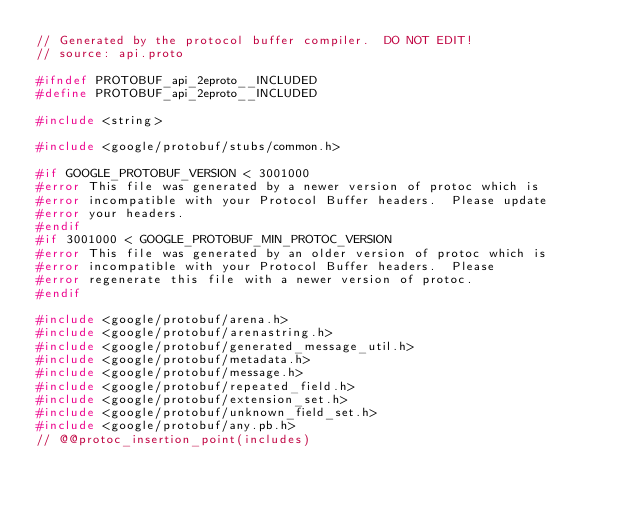Convert code to text. <code><loc_0><loc_0><loc_500><loc_500><_C_>// Generated by the protocol buffer compiler.  DO NOT EDIT!
// source: api.proto

#ifndef PROTOBUF_api_2eproto__INCLUDED
#define PROTOBUF_api_2eproto__INCLUDED

#include <string>

#include <google/protobuf/stubs/common.h>

#if GOOGLE_PROTOBUF_VERSION < 3001000
#error This file was generated by a newer version of protoc which is
#error incompatible with your Protocol Buffer headers.  Please update
#error your headers.
#endif
#if 3001000 < GOOGLE_PROTOBUF_MIN_PROTOC_VERSION
#error This file was generated by an older version of protoc which is
#error incompatible with your Protocol Buffer headers.  Please
#error regenerate this file with a newer version of protoc.
#endif

#include <google/protobuf/arena.h>
#include <google/protobuf/arenastring.h>
#include <google/protobuf/generated_message_util.h>
#include <google/protobuf/metadata.h>
#include <google/protobuf/message.h>
#include <google/protobuf/repeated_field.h>
#include <google/protobuf/extension_set.h>
#include <google/protobuf/unknown_field_set.h>
#include <google/protobuf/any.pb.h>
// @@protoc_insertion_point(includes)
</code> 